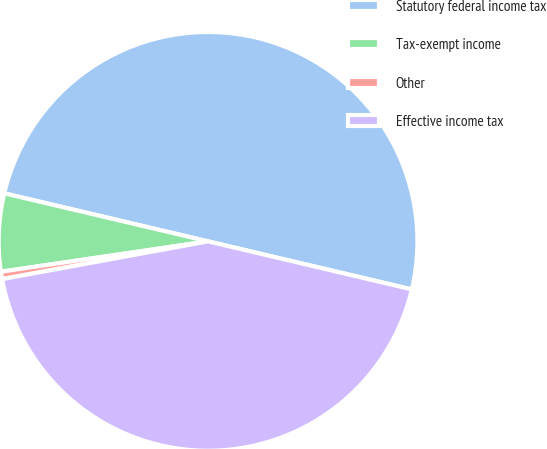<chart> <loc_0><loc_0><loc_500><loc_500><pie_chart><fcel>Statutory federal income tax<fcel>Tax-exempt income<fcel>Other<fcel>Effective income tax<nl><fcel>50.0%<fcel>6.0%<fcel>0.57%<fcel>43.43%<nl></chart> 